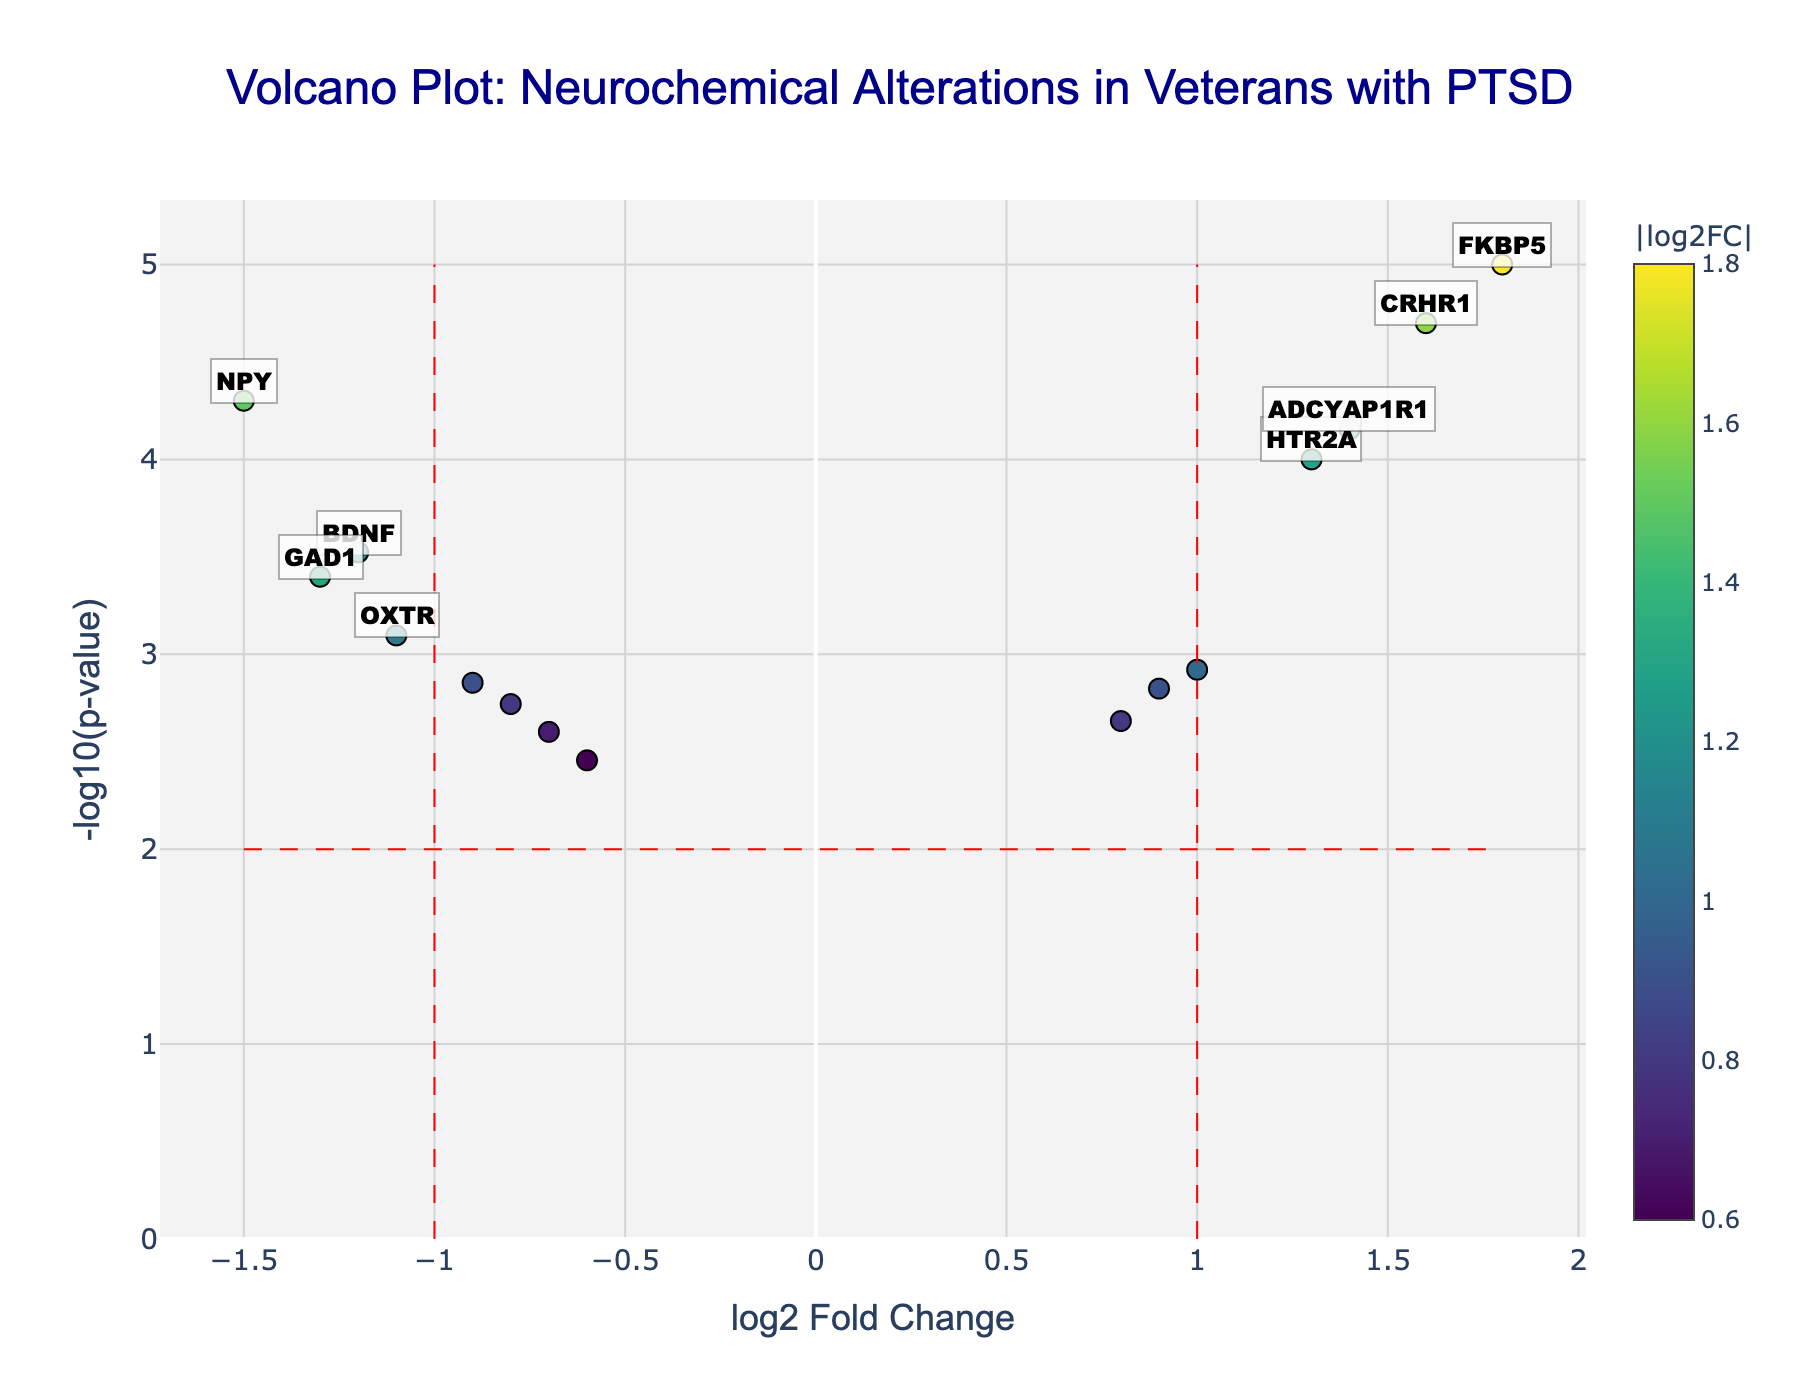What is the title of the volcano plot? The title is displayed at the top-center of the plot.
Answer: Volcano Plot: Neurochemical Alterations in Veterans with PTSD Which axis represents the log2 Fold Change? The x-axis is labeled 'log2 Fold Change', indicating it represents the log2 Fold Change values.
Answer: x-axis How many genes have a significantly high positive log2 Fold Change and very low p-value? Genes that meet these criteria will have markers in the upper-right corner, above the horizontal red line and to the right of the vertical red line. From the plot, these genes are FKBP5, CRHR1, HTR2A, ADCYAP1R1, and SLC6A3.
Answer: 5 genes Which gene has the highest negative log2 Fold Change and what is its p-value? This gene will be the one farthest to the left along the x-axis. From the plot, NPY has the highest negative log2 Fold Change of -1.5. The hover information reveals its p-value is 0.00005.
Answer: NPY; 0.00005 Which neurotransmitter-related gene has the highest positive log2 Fold Change? Identify the neurotransmitter-related genes and find the one with the highest positive log2FC. FKBP5 has the highest positive log2 Fold Change of 1.8.
Answer: FKBP5 Compare the log2 Fold Change of COMT and MAOA. Which one is more negative? COMT has a log2 Fold Change of -0.7, while MAOA has a log2 Fold Change of -0.6. By comparing these values, we see that COMT is more negative.
Answer: COMT What is the range of -log10(p-value) values? Determine the minimum and maximum along the y-axis. The minimum is slightly above 0 and the maximum is around 5.3.
Answer: 0 to 5.3 Name two genes with a log2 Fold Change of approximately 1 or higher and a p-value less than 0.01. Look for points around log2 Fold Change equal to or greater than 1 and check their p-values via the hover text. FKBP5 (1.8, 0.00001) and CRHR1 (1.6, 0.00002) fit this criteria.
Answer: FKBP5, CRHR1 